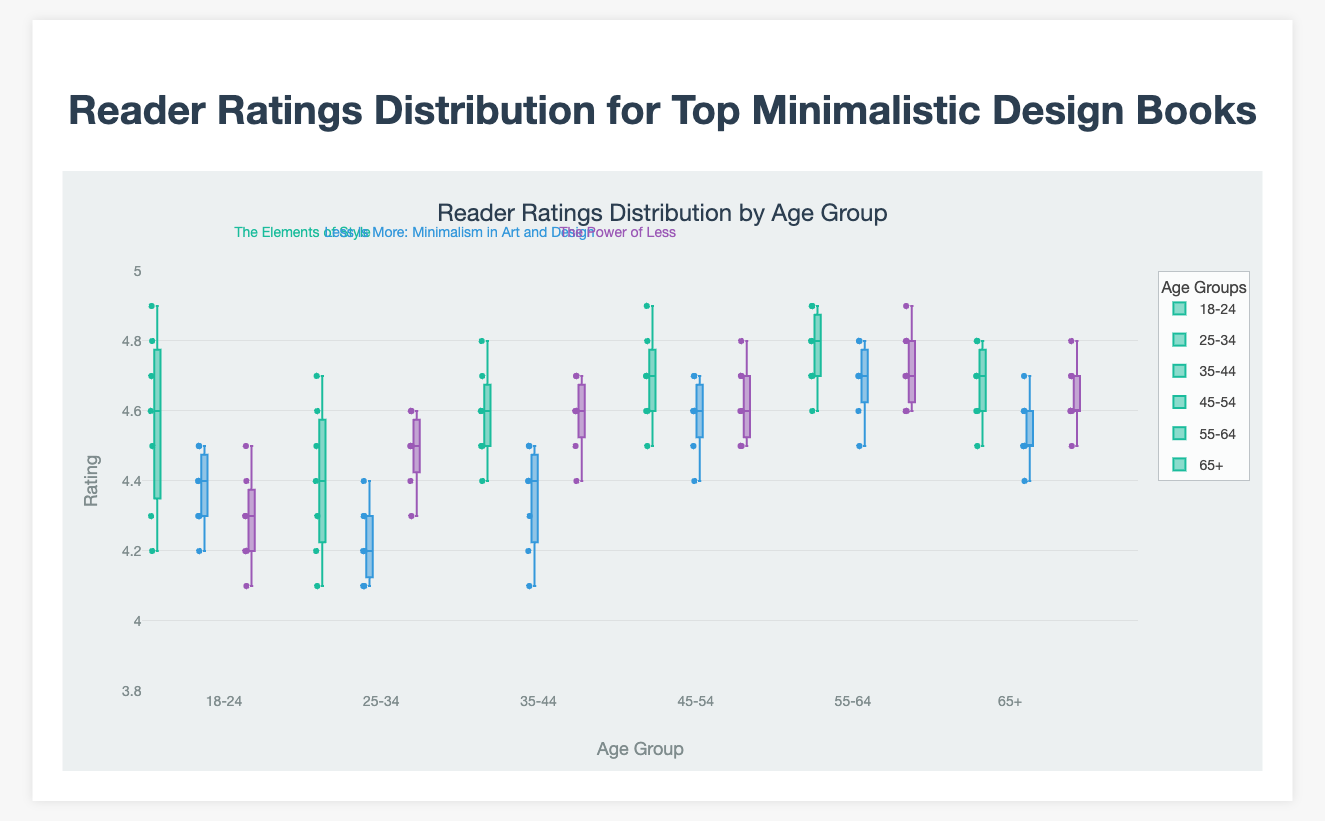How are the age groups ordered on the x-axis? The age groups are ordered from youngest to oldest: 18-24, 25-34, 35-44, 45-54, 55-64, and 65+. By observing the x-axis labels, one can confirm the order of the age groups.
Answer: "18-24", "25-34", "35-44", "45-54", "55-64", "65+" What is the median rating for the book "The Elements of Style" in the age group 25-34? To find the median rating for "The Elements of Style" in the age group 25-34, observe the horizontal line inside the box for this group. The median rating is around 4.4.
Answer: 4.4 Which book generally has the highest median ratings across all age groups? Compare the median rating lines across the boxes for all age groups. "The Elements of Style" consistently has higher medians.
Answer: "The Elements of Style" In the age group 55-64, which book has the widest range of reader ratings? The range of ratings is indicated by the distance between the whiskers of the boxplot. The book "The Elements of Style" has the widest range in the 55-64 age group.
Answer: "The Elements of Style" Do ratings tend to improve, decline, or stay the same as the age group increases for the book "The Power of Less"? By comparing the median lines for each age group, the ratings for "The Power of Less" generally improve with age. The median lines slightly increase as the age group increases.
Answer: Improve Which age group shows the least variability in ratings for "Less Is More: Minimalism in Art and Design"? Variability is shown by the length of the box and the distance between the whiskers. For "Less Is More", the age group 65+ shows the least variability.
Answer: 65+ Which book has the smallest interquartile range (IQR) in the age group 45-54? The IQR is represented by the height of the box. For the age group 45-54, "The Power of Less" has the smallest IQR.
Answer: "The Power of Less" Among the 18-24 age group, which book has the highest outlier rating? Look for data points outside the whiskers. "The Elements of Style" has the highest outlier rating for the 18-24 age group, about 4.9.
Answer: "The Elements of Style" How do the median ratings of "Less Is More: Minimalism in Art and Design" change across the first three age groups? Observing the horizontal median line in the boxes for the first three age groups for "Less Is More", the median slightly declines from 18-24 to 35-44.
Answer: Decline Which book shows the most consistent ratings across the age groups? Consistent ratings are indicated by less variability in median lines and smaller IQRs. "The Power of Less" shows the most consistency with relatively stable medians and small IQRs across age groups.
Answer: "The Power of Less" 